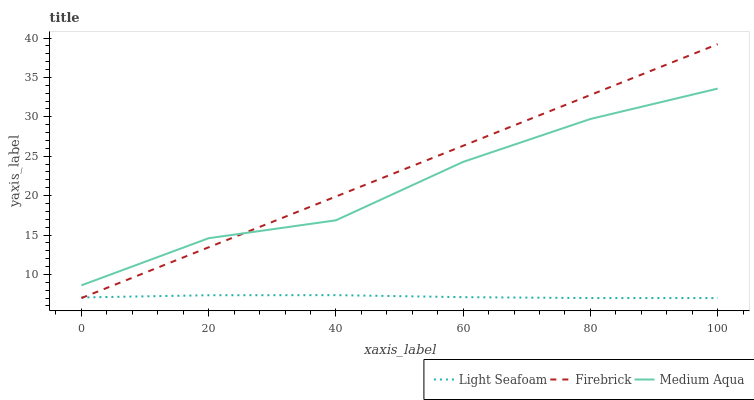Does Light Seafoam have the minimum area under the curve?
Answer yes or no. Yes. Does Firebrick have the maximum area under the curve?
Answer yes or no. Yes. Does Medium Aqua have the minimum area under the curve?
Answer yes or no. No. Does Medium Aqua have the maximum area under the curve?
Answer yes or no. No. Is Firebrick the smoothest?
Answer yes or no. Yes. Is Medium Aqua the roughest?
Answer yes or no. Yes. Is Light Seafoam the smoothest?
Answer yes or no. No. Is Light Seafoam the roughest?
Answer yes or no. No. Does Firebrick have the lowest value?
Answer yes or no. Yes. Does Medium Aqua have the lowest value?
Answer yes or no. No. Does Firebrick have the highest value?
Answer yes or no. Yes. Does Medium Aqua have the highest value?
Answer yes or no. No. Is Light Seafoam less than Medium Aqua?
Answer yes or no. Yes. Is Medium Aqua greater than Light Seafoam?
Answer yes or no. Yes. Does Firebrick intersect Light Seafoam?
Answer yes or no. Yes. Is Firebrick less than Light Seafoam?
Answer yes or no. No. Is Firebrick greater than Light Seafoam?
Answer yes or no. No. Does Light Seafoam intersect Medium Aqua?
Answer yes or no. No. 